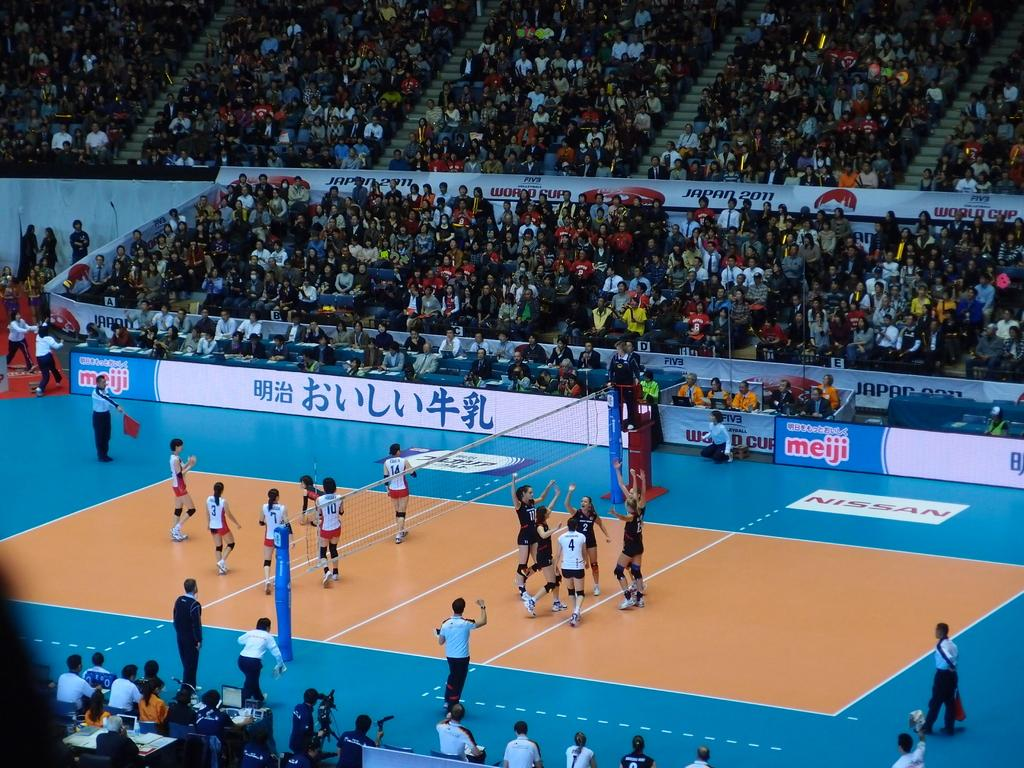<image>
Provide a brief description of the given image. A voyeball game with an ad for Meiji in the background. 